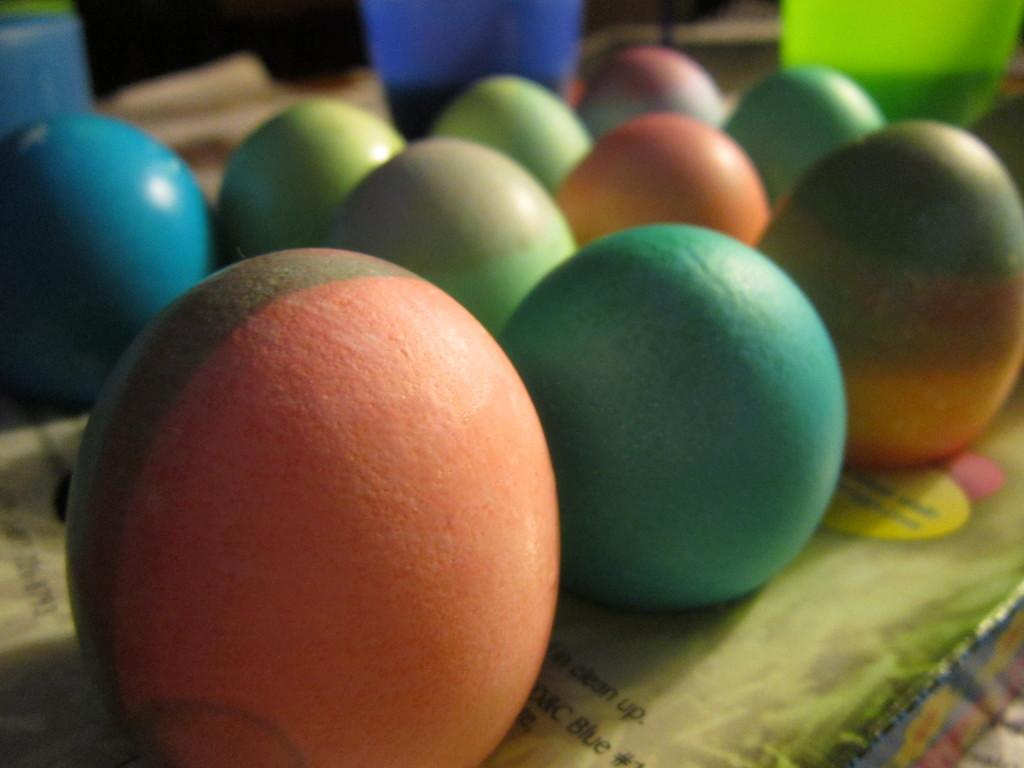What is the main subject of the image? The main subject of the image is a collection of colorful eggs. What other colorful items can be seen in the image? There are colorful objects at the top of the image. What is located at the bottom of the image? There appears to be a book at the bottom of the image. What type of hen is depicted in the image? There is no hen present in the image; it features a collection of colorful eggs and other colorful objects. How many teeth can be seen in the mouth of the person in the image? There is no person or mouth visible in the image; it features a collection of colorful eggs, colorful objects, and a book. 